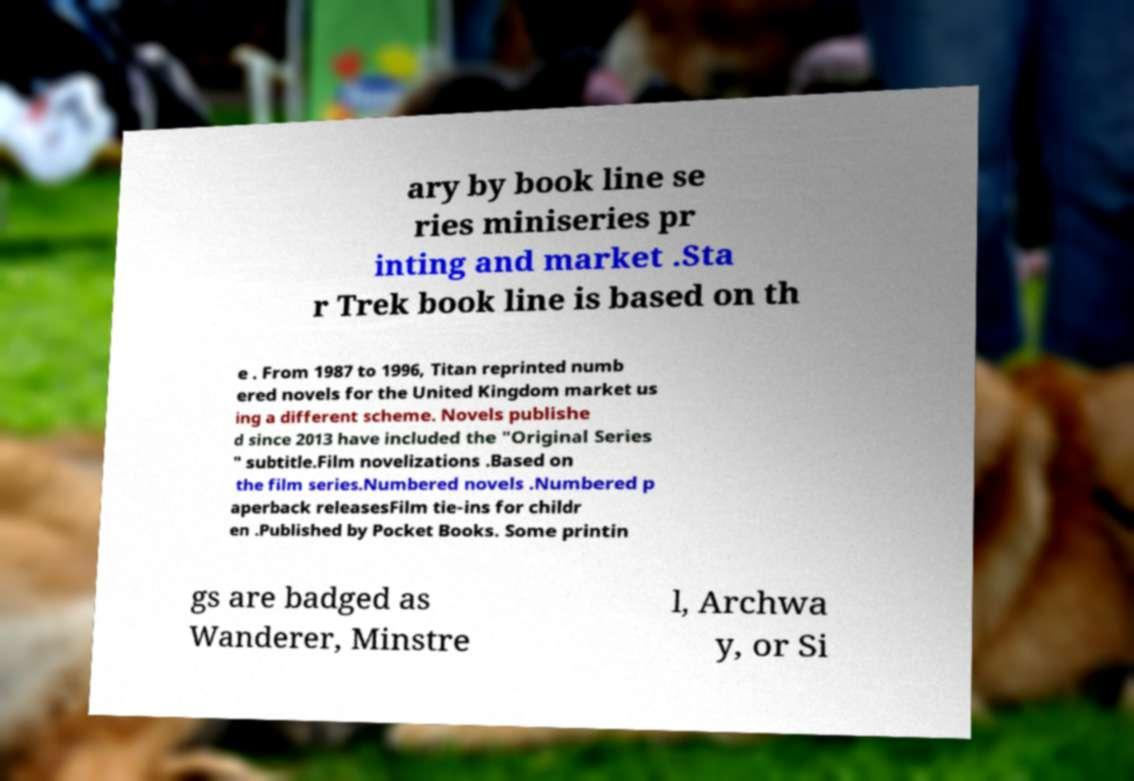There's text embedded in this image that I need extracted. Can you transcribe it verbatim? ary by book line se ries miniseries pr inting and market .Sta r Trek book line is based on th e . From 1987 to 1996, Titan reprinted numb ered novels for the United Kingdom market us ing a different scheme. Novels publishe d since 2013 have included the "Original Series " subtitle.Film novelizations .Based on the film series.Numbered novels .Numbered p aperback releasesFilm tie-ins for childr en .Published by Pocket Books. Some printin gs are badged as Wanderer, Minstre l, Archwa y, or Si 